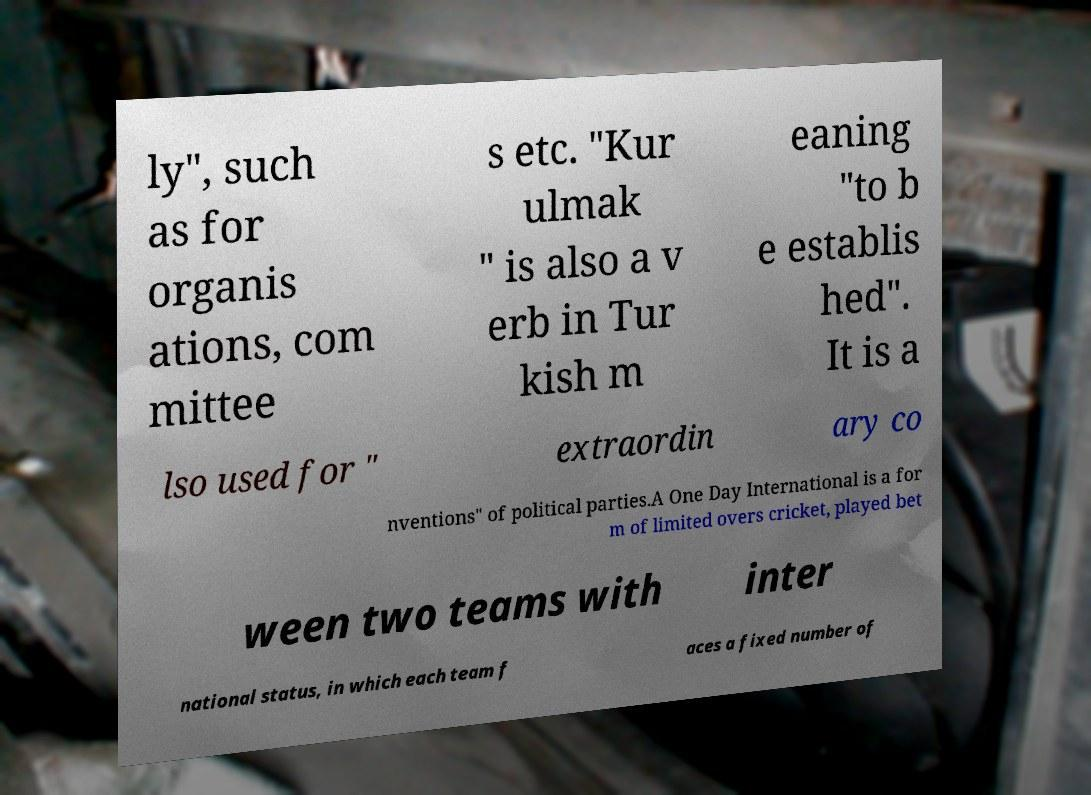Can you read and provide the text displayed in the image?This photo seems to have some interesting text. Can you extract and type it out for me? ly", such as for organis ations, com mittee s etc. "Kur ulmak " is also a v erb in Tur kish m eaning "to b e establis hed". It is a lso used for " extraordin ary co nventions" of political parties.A One Day International is a for m of limited overs cricket, played bet ween two teams with inter national status, in which each team f aces a fixed number of 